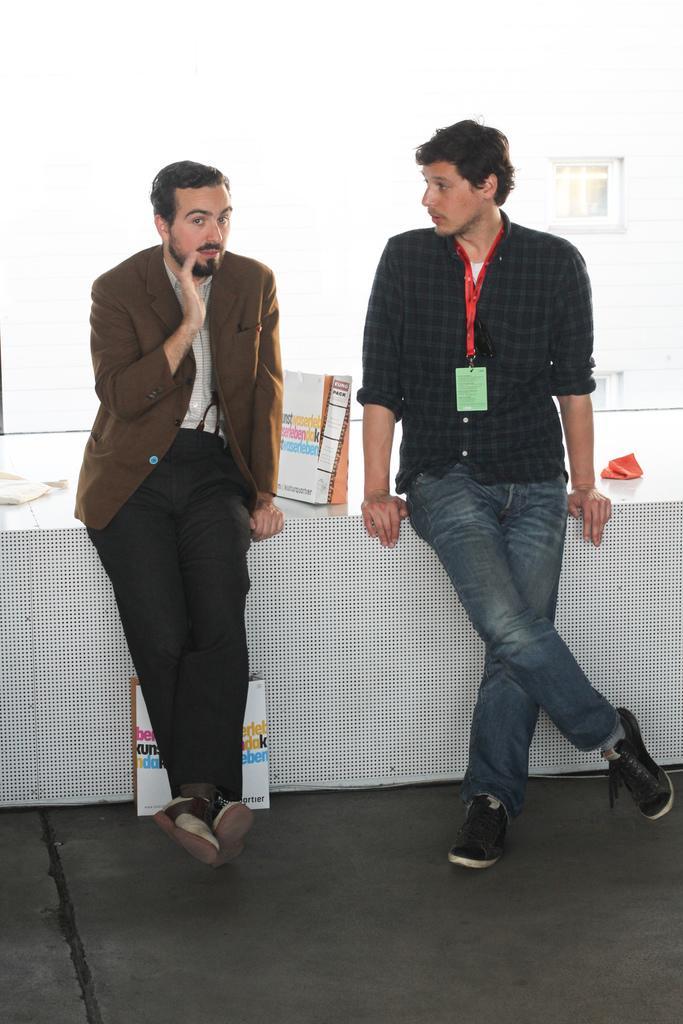Could you give a brief overview of what you see in this image? In this image we can see two persons are sitting on a table. There are few objects on the table. There is a window of another building behind the person. There is an object placed on the surface in the image. 